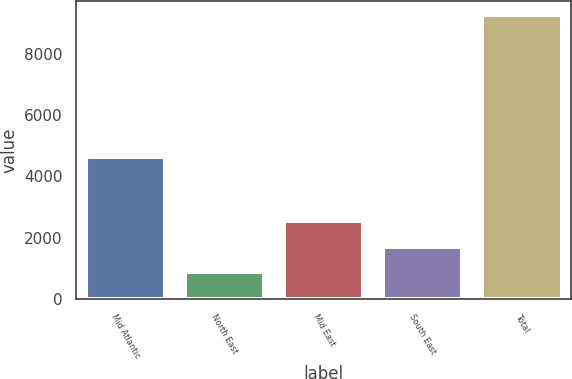Convert chart to OTSL. <chart><loc_0><loc_0><loc_500><loc_500><bar_chart><fcel>Mid Atlantic<fcel>North East<fcel>Mid East<fcel>South East<fcel>Total<nl><fcel>4616<fcel>872<fcel>2547<fcel>1709.5<fcel>9247<nl></chart> 